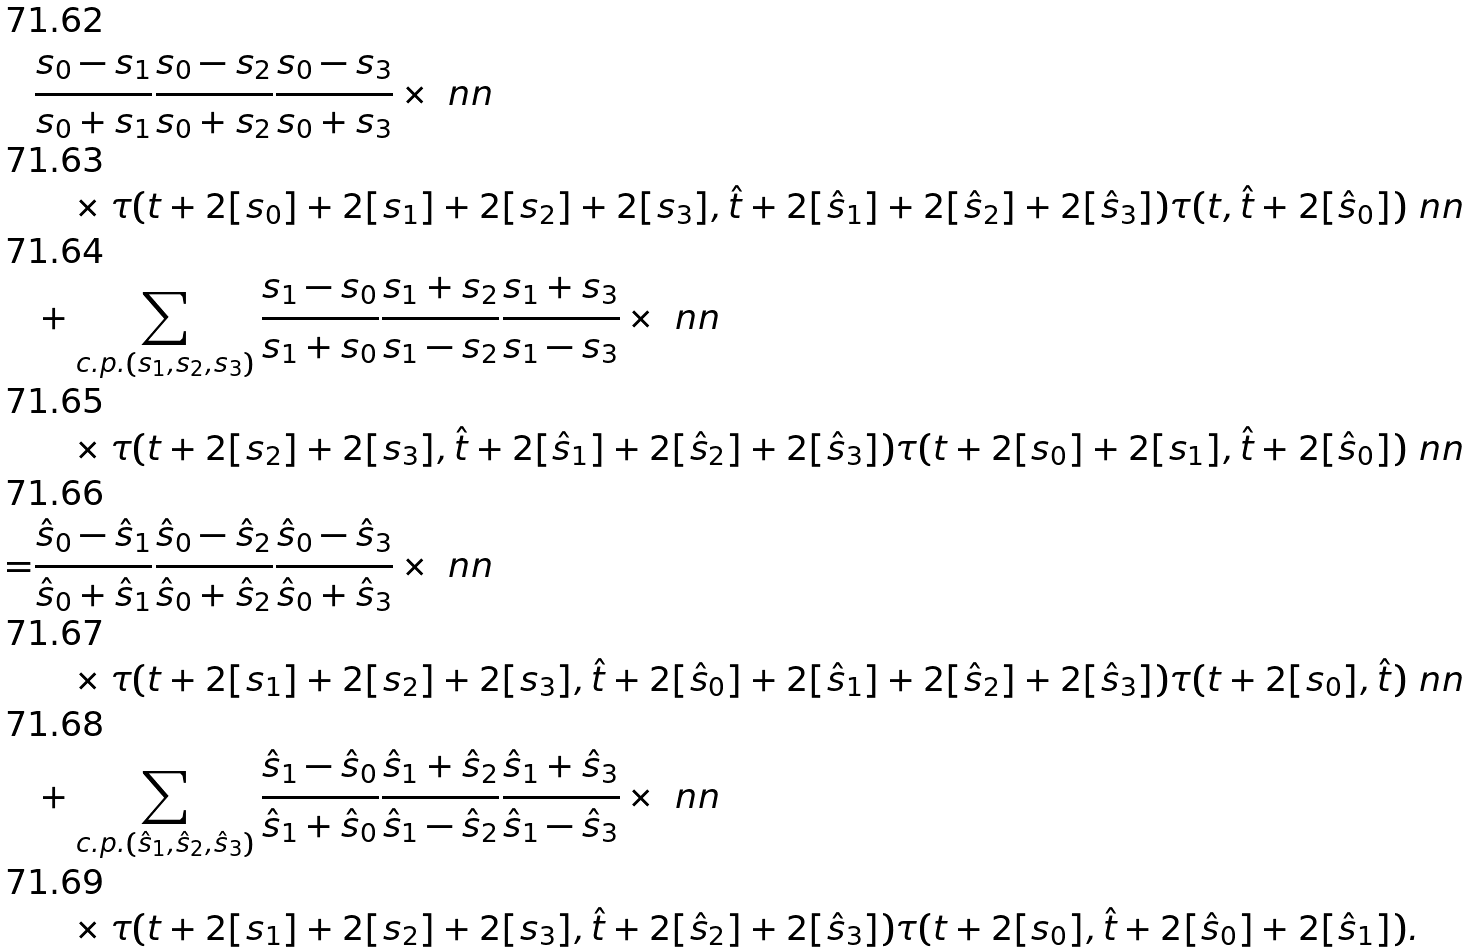<formula> <loc_0><loc_0><loc_500><loc_500>& \frac { s _ { 0 } - s _ { 1 } } { s _ { 0 } + s _ { 1 } } \frac { s _ { 0 } - s _ { 2 } } { s _ { 0 } + s _ { 2 } } \frac { s _ { 0 } - s _ { 3 } } { s _ { 0 } + s _ { 3 } } \times \ n n \\ & \quad \times \tau ( { t } + 2 [ s _ { 0 } ] + 2 [ s _ { 1 } ] + 2 [ s _ { 2 } ] + 2 [ s _ { 3 } ] , \hat { t } + 2 [ \hat { s } _ { 1 } ] + 2 [ \hat { s } _ { 2 } ] + 2 [ \hat { s } _ { 3 } ] ) \tau ( { t } , \hat { t } + 2 [ \hat { s } _ { 0 } ] ) \ n n \\ & + \sum _ { c . p . ( s _ { 1 } , s _ { 2 } , s _ { 3 } ) } \frac { s _ { 1 } - s _ { 0 } } { s _ { 1 } + s _ { 0 } } \frac { s _ { 1 } + s _ { 2 } } { s _ { 1 } - s _ { 2 } } \frac { s _ { 1 } + s _ { 3 } } { s _ { 1 } - s _ { 3 } } \times \ n n \\ & \quad \times \tau ( { t } + 2 [ s _ { 2 } ] + 2 [ s _ { 3 } ] , \hat { t } + 2 [ \hat { s } _ { 1 } ] + 2 [ \hat { s } _ { 2 } ] + 2 [ \hat { s } _ { 3 } ] ) \tau ( { t } + 2 [ s _ { 0 } ] + 2 [ s _ { 1 } ] , \hat { t } + 2 [ \hat { s } _ { 0 } ] ) \ n n \\ = & \frac { \hat { s } _ { 0 } - \hat { s } _ { 1 } } { \hat { s } _ { 0 } + \hat { s } _ { 1 } } \frac { \hat { s } _ { 0 } - \hat { s } _ { 2 } } { \hat { s } _ { 0 } + \hat { s } _ { 2 } } \frac { \hat { s } _ { 0 } - \hat { s } _ { 3 } } { \hat { s } _ { 0 } + \hat { s } _ { 3 } } \times \ n n \\ & \quad \times \tau ( { t } + 2 [ s _ { 1 } ] + 2 [ s _ { 2 } ] + 2 [ s _ { 3 } ] , \hat { t } + 2 [ \hat { s } _ { 0 } ] + 2 [ \hat { s } _ { 1 } ] + 2 [ \hat { s } _ { 2 } ] + 2 [ \hat { s } _ { 3 } ] ) \tau ( { t } + 2 [ s _ { 0 } ] , \hat { t } ) \ n n \\ & + \sum _ { c . p . ( \hat { s } _ { 1 } , \hat { s } _ { 2 } , \hat { s } _ { 3 } ) } \frac { \hat { s } _ { 1 } - \hat { s } _ { 0 } } { \hat { s } _ { 1 } + \hat { s } _ { 0 } } \frac { \hat { s } _ { 1 } + \hat { s } _ { 2 } } { \hat { s } _ { 1 } - \hat { s } _ { 2 } } \frac { \hat { s } _ { 1 } + \hat { s } _ { 3 } } { \hat { s } _ { 1 } - \hat { s } _ { 3 } } \times \ n n \\ & \quad \times \tau ( { t } + 2 [ s _ { 1 } ] + 2 [ s _ { 2 } ] + 2 [ s _ { 3 } ] , \hat { t } + 2 [ \hat { s } _ { 2 } ] + 2 [ \hat { s } _ { 3 } ] ) \tau ( { t } + 2 [ s _ { 0 } ] , \hat { t } + 2 [ \hat { s } _ { 0 } ] + 2 [ \hat { s } _ { 1 } ] ) .</formula> 